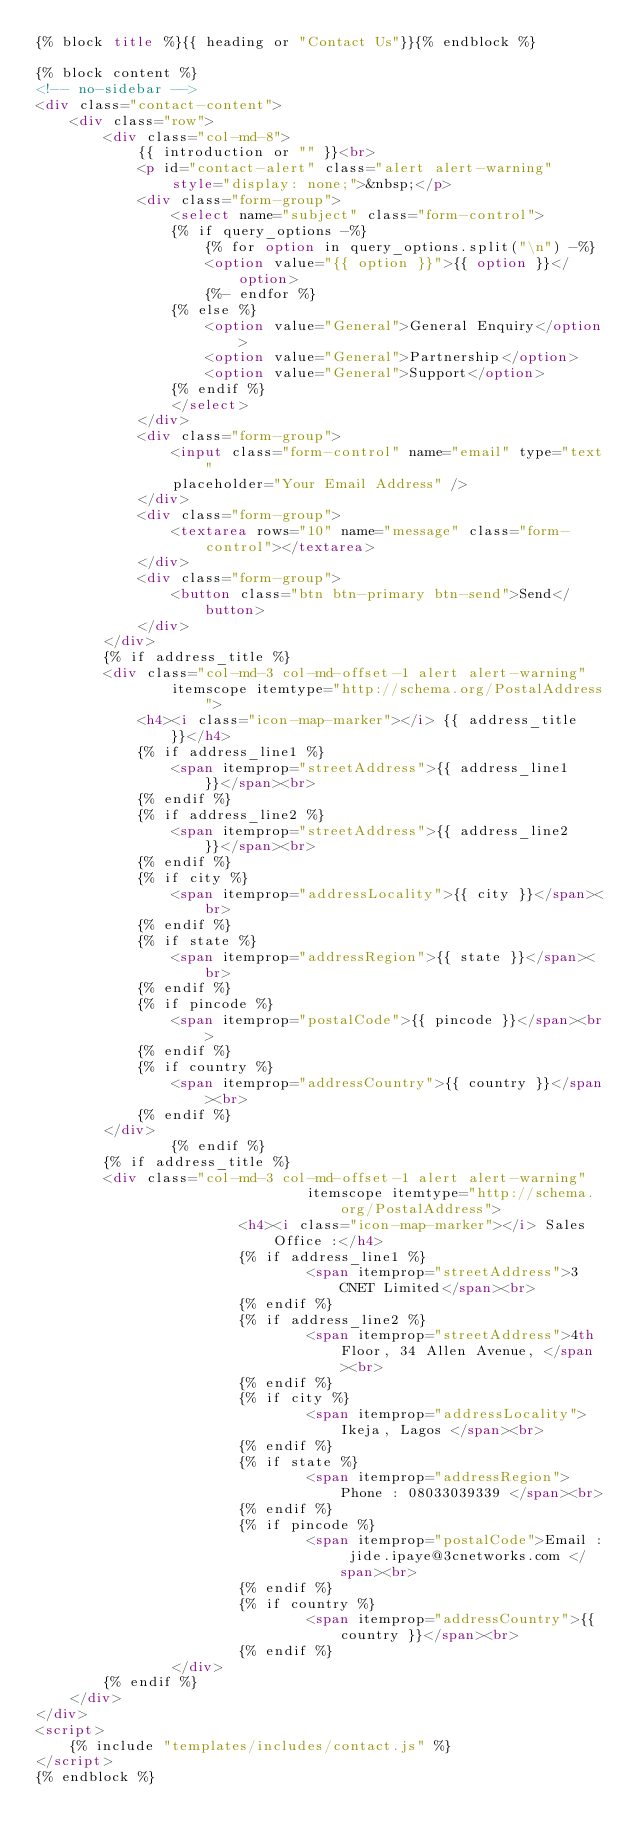<code> <loc_0><loc_0><loc_500><loc_500><_HTML_>{% block title %}{{ heading or "Contact Us"}}{% endblock %}

{% block content %}
<!-- no-sidebar -->
<div class="contact-content">
	<div class="row">
		<div class="col-md-8">
			{{ introduction or "" }}<br>
			<p id="contact-alert" class="alert alert-warning"
				style="display: none;">&nbsp;</p>
			<div class="form-group">
				<select name="subject" class="form-control">
				{% if query_options -%}
					{% for option in query_options.split("\n") -%}
					<option value="{{ option }}">{{ option }}</option>
					{%- endfor %}
				{% else %}
					<option value="General">General Enquiry</option>
					<option value="General">Partnership</option>
					<option value="General">Support</option>
				{% endif %}
				</select>
			</div>
			<div class="form-group">
				<input class="form-control" name="email" type="text"
				placeholder="Your Email Address" />
			</div>
			<div class="form-group">
				<textarea rows="10" name="message" class="form-control"></textarea>
			</div>
			<div class="form-group">
				<button class="btn btn-primary btn-send">Send</button>
			</div>
		</div>
		{% if address_title %}
		<div class="col-md-3 col-md-offset-1 alert alert-warning"
				itemscope itemtype="http://schema.org/PostalAddress">
			<h4><i class="icon-map-marker"></i> {{ address_title }}</h4>
			{% if address_line1 %}
				<span itemprop="streetAddress">{{ address_line1 }}</span><br>
			{% endif %}
			{% if address_line2 %}
				<span itemprop="streetAddress">{{ address_line2 }}</span><br>
			{% endif %}
			{% if city %}
				<span itemprop="addressLocality">{{ city }}</span><br>
			{% endif %}
			{% if state %}
				<span itemprop="addressRegion">{{ state }}</span><br>
			{% endif %}
			{% if pincode %}
				<span itemprop="postalCode">{{ pincode }}</span><br>
			{% endif %}
			{% if country %}
				<span itemprop="addressCountry">{{ country }}</span><br>
			{% endif %}
		</div>
                {% endif %}
		{% if address_title %}
		<div class="col-md-3 col-md-offset-1 alert alert-warning"
                                itemscope itemtype="http://schema.org/PostalAddress">
                        <h4><i class="icon-map-marker"></i> Sales Office :</h4>
                        {% if address_line1 %}
                                <span itemprop="streetAddress">3CNET Limited</span><br>
                        {% endif %}
                        {% if address_line2 %}
                                <span itemprop="streetAddress">4th Floor, 34 Allen Avenue, </span><br>
                        {% endif %}
                        {% if city %}
                                <span itemprop="addressLocality">Ikeja, Lagos </span><br>
                        {% endif %}
                        {% if state %}
                                <span itemprop="addressRegion">Phone : 08033039339 </span><br>
                        {% endif %}
                        {% if pincode %}
                                <span itemprop="postalCode">Email : jide.ipaye@3cnetworks.com </span><br>
                        {% endif %}
                        {% if country %}
                                <span itemprop="addressCountry">{{ country }}</span><br>
                        {% endif %}
                </div>
		{% endif %}
	</div>
</div>
<script>
	{% include "templates/includes/contact.js" %}
</script>
{% endblock %}
</code> 